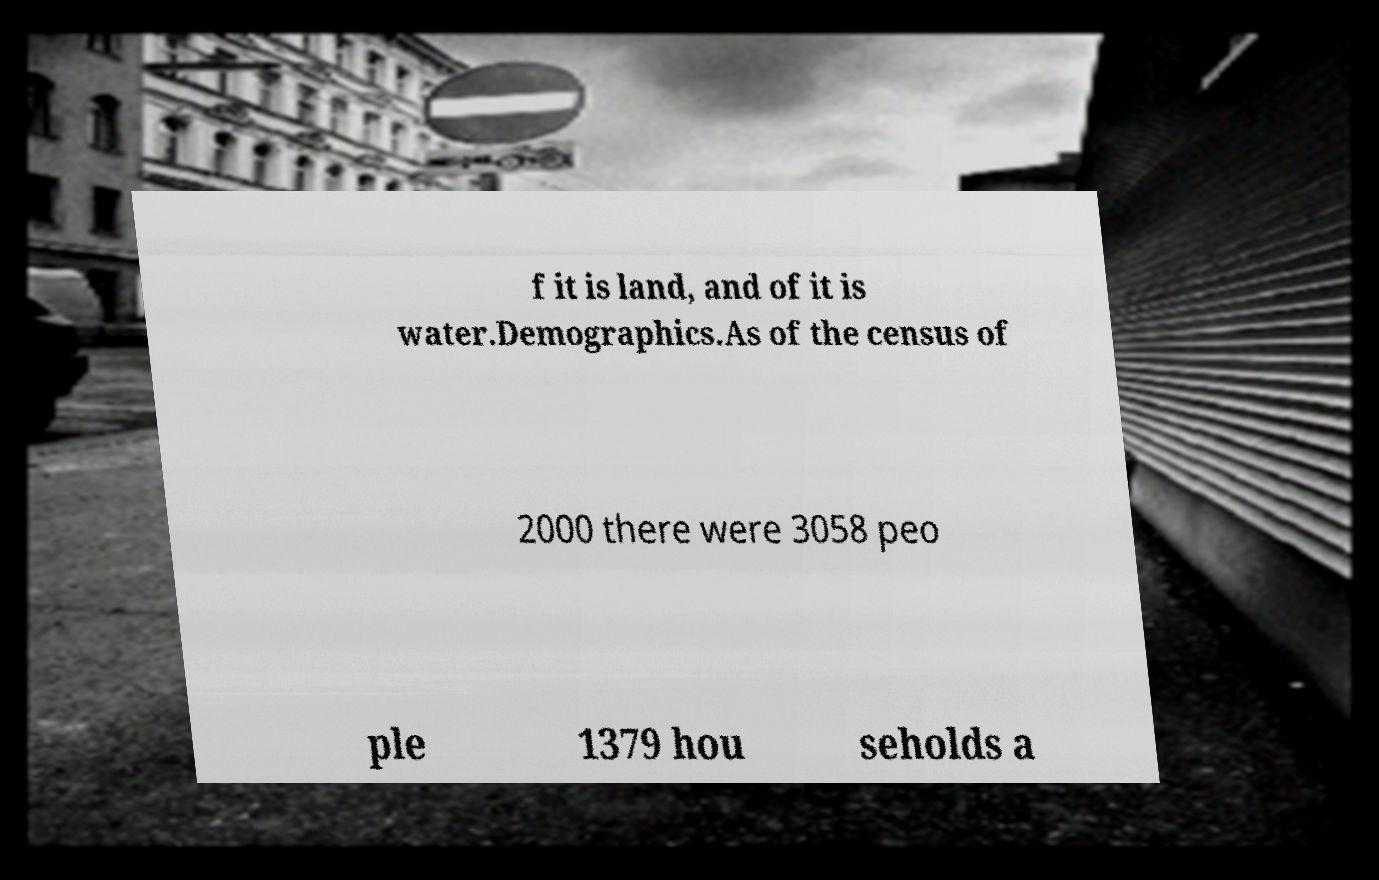Can you read and provide the text displayed in the image?This photo seems to have some interesting text. Can you extract and type it out for me? f it is land, and of it is water.Demographics.As of the census of 2000 there were 3058 peo ple 1379 hou seholds a 